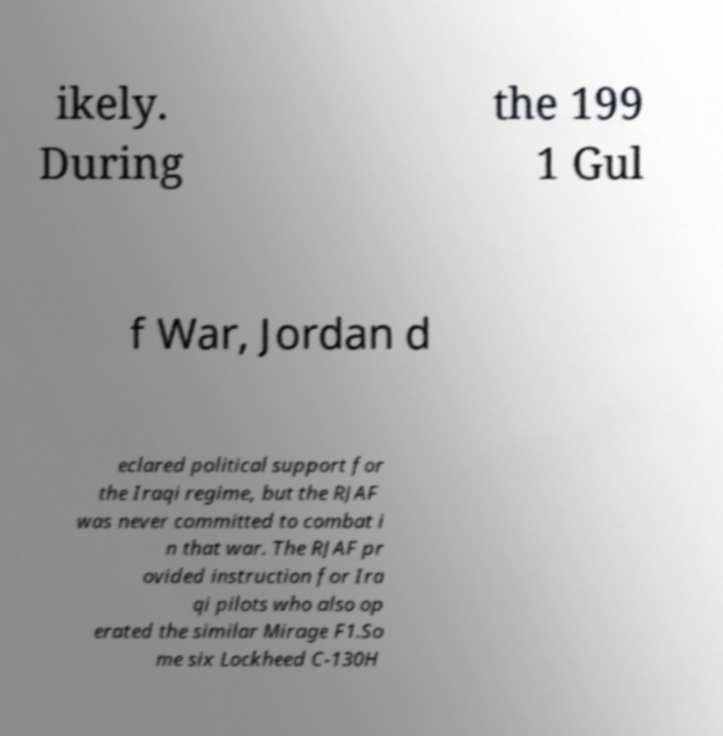What messages or text are displayed in this image? I need them in a readable, typed format. ikely. During the 199 1 Gul f War, Jordan d eclared political support for the Iraqi regime, but the RJAF was never committed to combat i n that war. The RJAF pr ovided instruction for Ira qi pilots who also op erated the similar Mirage F1.So me six Lockheed C-130H 